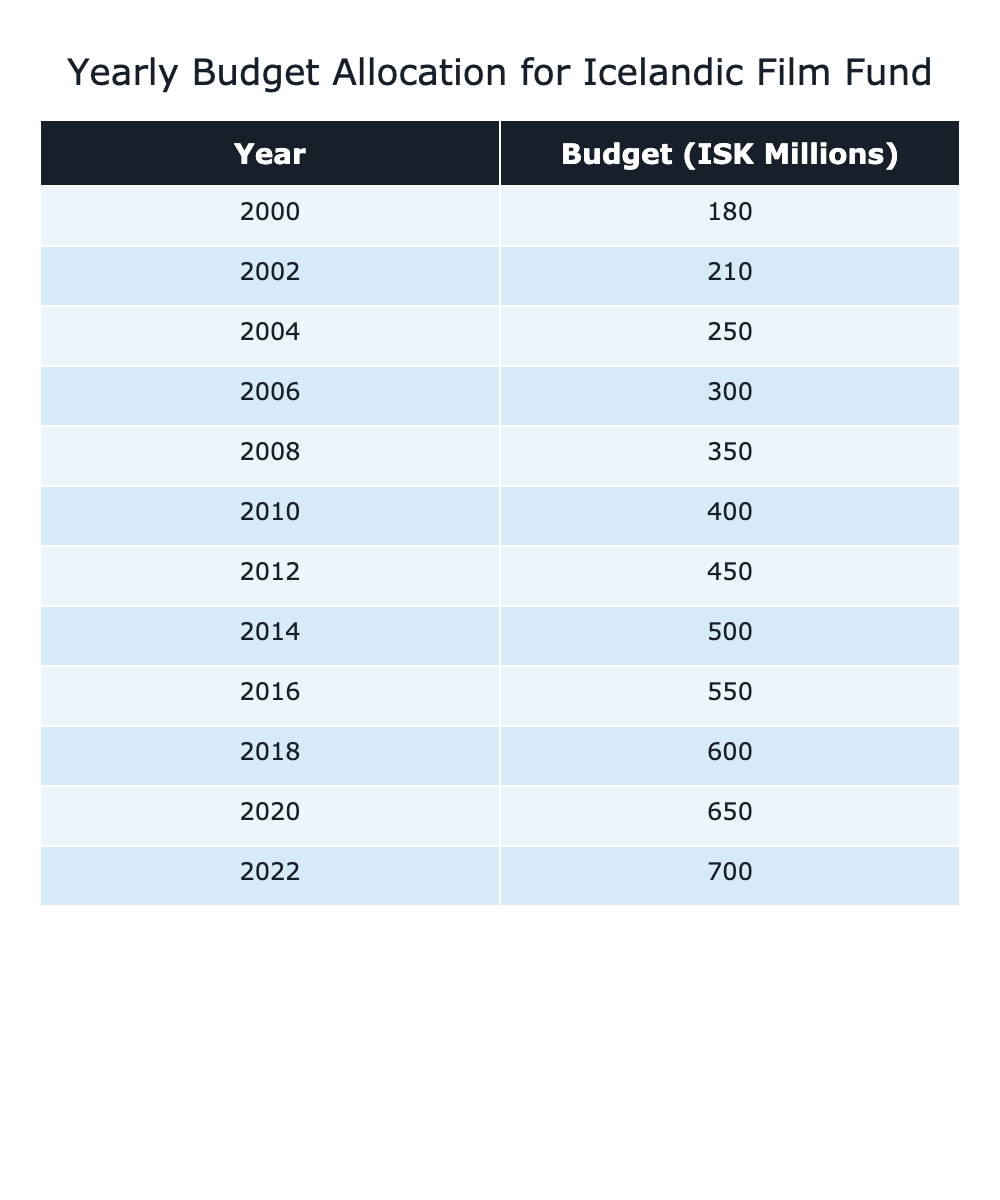What was the budget for the Icelandic Film Fund in 2000? The table shows that in the year 2000, the budget was 180 million ISK.
Answer: 180 million ISK What was the budget in 2022 compared to 2008? In 2022, the budget was 700 million ISK and in 2008 it was 350 million ISK. The difference is 700 - 350 = 350 million ISK.
Answer: 350 million ISK Was there an increase in budget allocation from 2010 to 2016? In 2010, the budget was 400 million ISK, and in 2016, it was 550 million ISK. Since 550 is greater than 400, there was an increase.
Answer: Yes What is the total budget allocation for the years in the table? To find the total, sum all the budget values: 180 + 210 + 250 + 300 + 350 + 400 + 450 + 500 + 550 + 600 + 650 + 700 = 5,540 million ISK.
Answer: 5,540 million ISK What is the average budget allocation from 2000 to 2022? First, find the total budget (5,540 million ISK) and the number of years (12). Then calculate the average: 5,540 / 12 = 461.67 million ISK.
Answer: 461.67 million ISK Which year had the largest budget increase compared to the previous year? By examining the table, the largest increase is from 2020 (650 million ISK) to 2022 (700 million ISK), which is an increase of 50 million ISK.
Answer: 50 million ISK Is the budget in 2014 greater than the average budget from 2000 to 2022? The budget for 2014 was 500 million ISK, and the average budget is approximately 461.67 million ISK. Since 500 is greater than 461.67, the statement is true.
Answer: Yes What is the percentage increase of the budget from 2000 to 2022? The budget in 2000 was 180 million ISK and in 2022 it was 700 million ISK. Calculate the increase: (700 - 180) = 520 million ISK. The percentage is (520 / 180) * 100 = 288.89%.
Answer: 288.89% How many years had a budget of over 600 million ISK? By checking the table, the years with a budget greater than 600 million ISK are 2018 (600), 2020 (650), and 2022 (700). Therefore, there are 3 such years.
Answer: 3 What year(s) saw a budget of 500 million ISK exactly? Checking the table, the year 2014 shows a budget of 500 million ISK. No other year matches this value.
Answer: 2014 